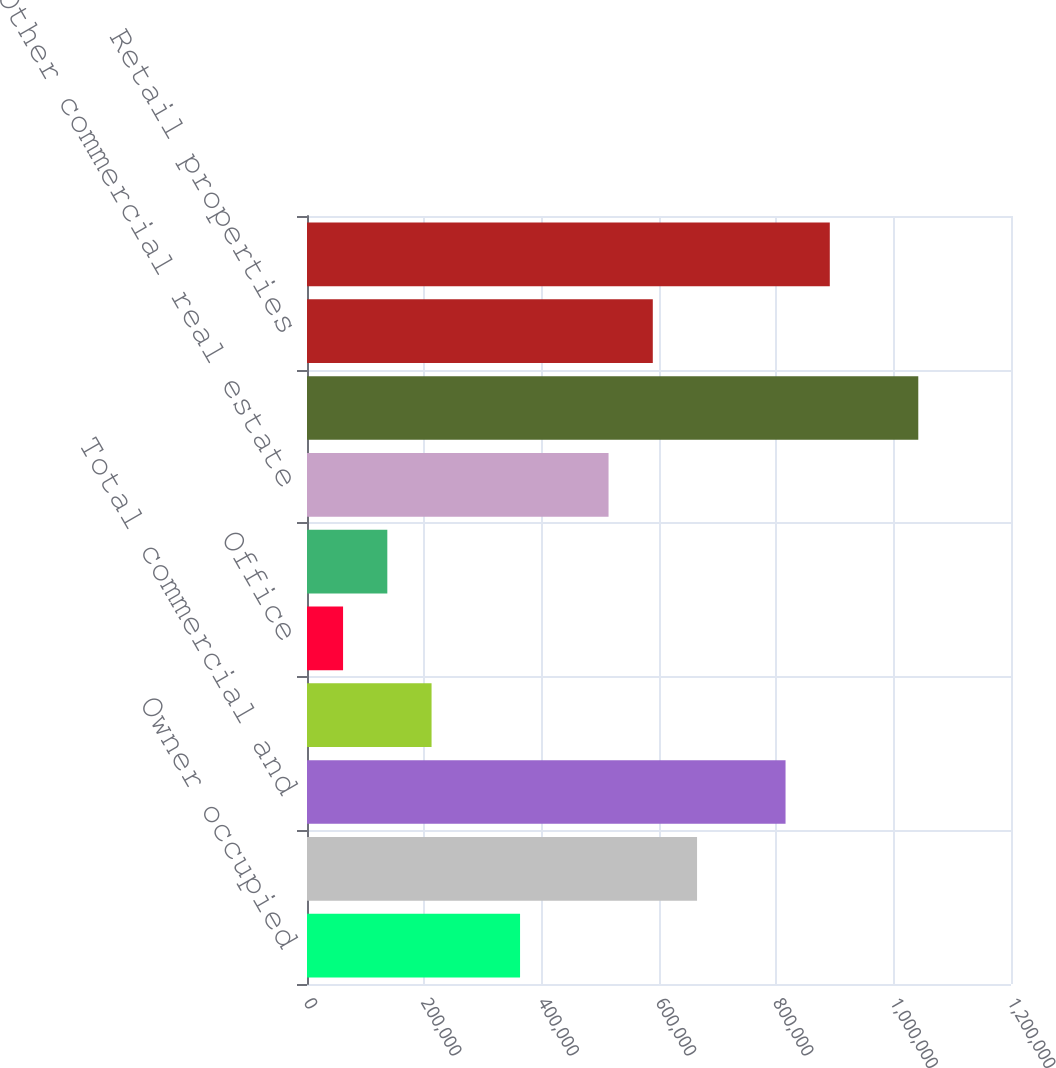Convert chart to OTSL. <chart><loc_0><loc_0><loc_500><loc_500><bar_chart><fcel>Owner occupied<fcel>Other commercial and<fcel>Total commercial and<fcel>Multi family<fcel>Office<fcel>Industrial and warehouse<fcel>Other commercial real estate<fcel>Total commercial real estate<fcel>Retail properties<fcel>Automobile<nl><fcel>363166<fcel>664855<fcel>815700<fcel>212321<fcel>61476<fcel>136898<fcel>514010<fcel>1.04197e+06<fcel>589433<fcel>891122<nl></chart> 